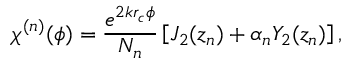<formula> <loc_0><loc_0><loc_500><loc_500>\chi ^ { ( n ) } ( \phi ) = \frac { e ^ { 2 k r _ { c } \phi } } { N _ { n } } \left [ J _ { 2 } ( z _ { n } ) + \alpha _ { n } Y _ { 2 } ( z _ { n } ) \right ] ,</formula> 